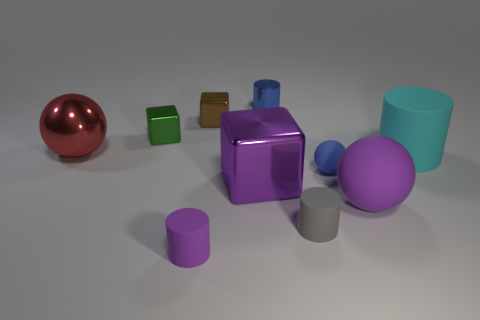There is a tiny blue thing that is behind the large red shiny sphere; what number of large cyan matte objects are behind it?
Your response must be concise. 0. Are there any brown objects left of the green block?
Your answer should be compact. No. What shape is the large object that is to the left of the small metallic cube right of the green block?
Provide a short and direct response. Sphere. Is the number of large purple rubber spheres that are left of the purple matte sphere less than the number of cubes on the right side of the small gray object?
Offer a terse response. No. The big object that is the same shape as the tiny purple object is what color?
Offer a terse response. Cyan. What number of large objects are left of the blue sphere and in front of the small blue rubber sphere?
Offer a terse response. 1. Are there more tiny brown blocks in front of the gray object than big balls left of the small green thing?
Offer a terse response. No. The blue cylinder is what size?
Your response must be concise. Small. Are there any small blue metal things that have the same shape as the green object?
Make the answer very short. No. Does the purple metal object have the same shape as the big matte thing that is behind the big purple rubber ball?
Provide a succinct answer. No. 